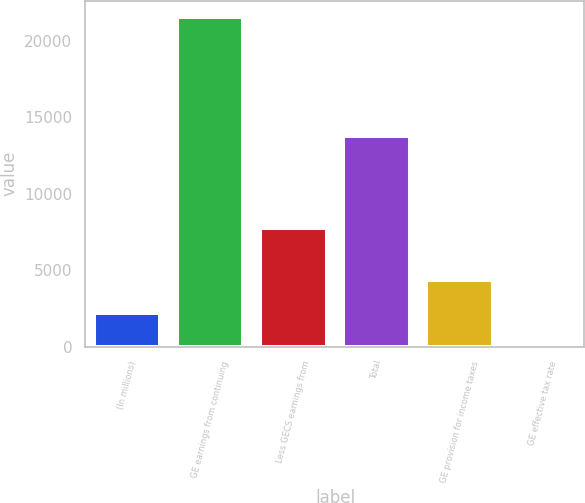Convert chart. <chart><loc_0><loc_0><loc_500><loc_500><bar_chart><fcel>(In millions)<fcel>GE earnings from continuing<fcel>Less GECS earnings from<fcel>Total<fcel>GE provision for income taxes<fcel>GE effective tax rate<nl><fcel>2174.01<fcel>21516<fcel>7774<fcel>13742<fcel>4323.12<fcel>24.9<nl></chart> 